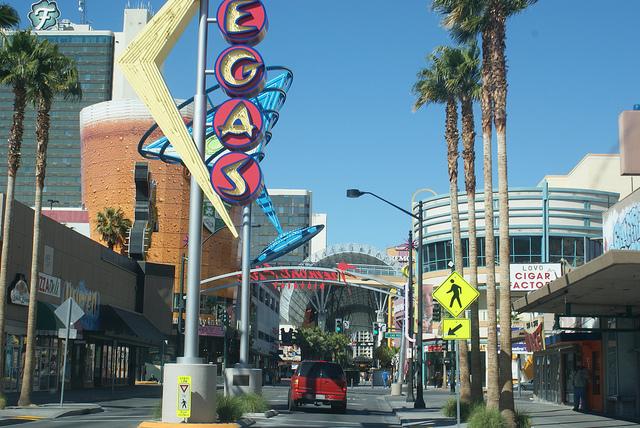Does the hotel begin with f?
Concise answer only. No. What kind of trees are here?
Give a very brief answer. Palm. What city is this?
Give a very brief answer. Las vegas. 